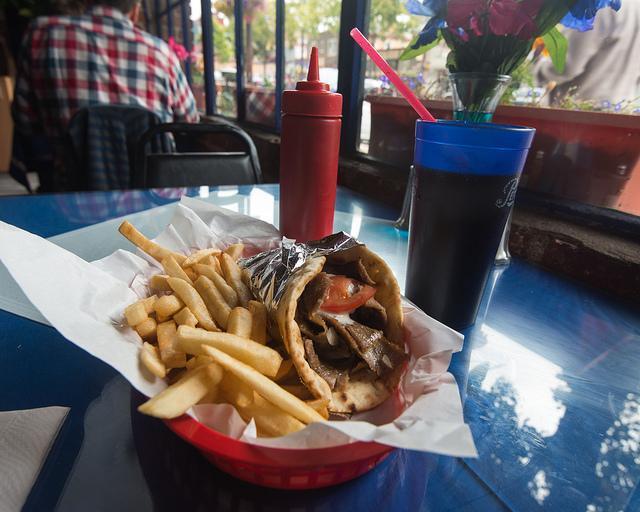How many sandwiches are there?
Give a very brief answer. 1. How many chairs are there?
Give a very brief answer. 2. How many people are in the picture?
Give a very brief answer. 2. How many vases are there?
Give a very brief answer. 1. How many cows are here?
Give a very brief answer. 0. 